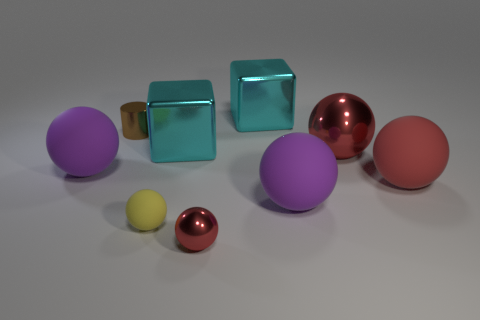Is the size of the purple thing that is in front of the red matte object the same as the cylinder behind the tiny metallic ball?
Your answer should be compact. No. What number of other things are there of the same size as the red rubber sphere?
Offer a very short reply. 5. What material is the big red sphere that is behind the purple rubber sphere left of the block that is behind the metal cylinder made of?
Provide a succinct answer. Metal. There is a cylinder; is its size the same as the purple rubber sphere on the left side of the brown thing?
Your response must be concise. No. What is the size of the red ball that is in front of the large red metal thing and to the left of the large red matte object?
Keep it short and to the point. Small. Are there any other spheres that have the same color as the large metallic ball?
Keep it short and to the point. Yes. The metal sphere that is in front of the big ball that is in front of the large red rubber object is what color?
Provide a succinct answer. Red. Are there fewer metal objects left of the brown metal cylinder than large rubber things left of the big red metal ball?
Offer a terse response. Yes. Is the yellow object the same size as the red matte object?
Offer a very short reply. No. What shape is the object that is on the left side of the small yellow rubber object and in front of the cylinder?
Your answer should be very brief. Sphere. 